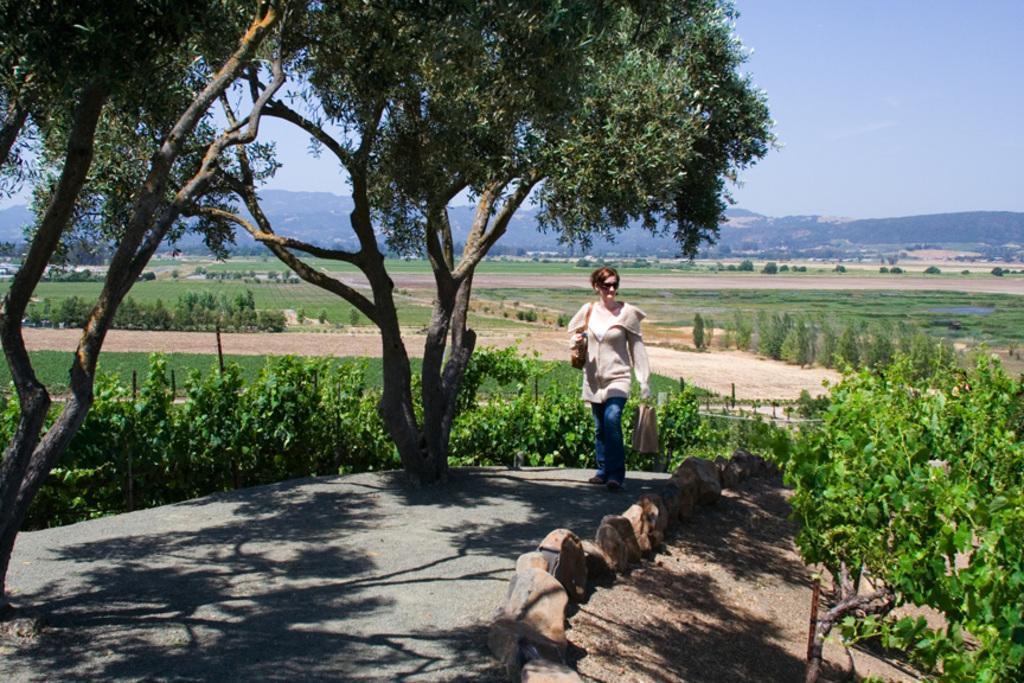Could you give a brief overview of what you see in this image? In the image there is a woman, around her there are trees, plants, crops and in the background there are mountains. 